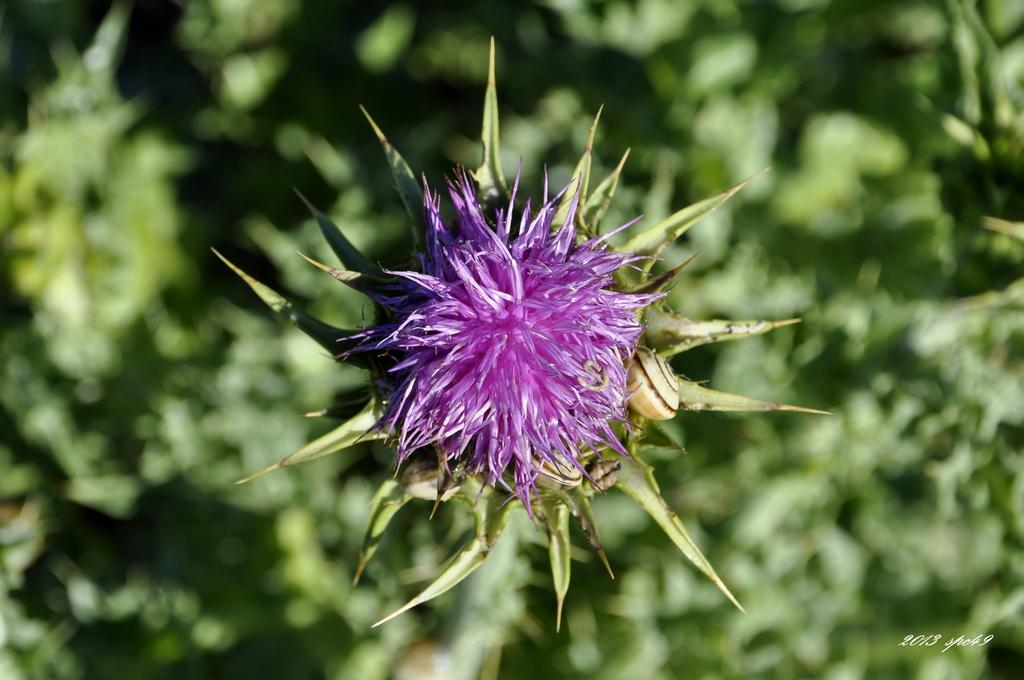What type of plant is visible in the image? There is a flower in the image. What else can be seen around the flower? There are leaves around the flower. What is written at the bottom of the image? There is some text at the bottom of the image. What else is present at the bottom of the image besides the text? There are numbers at the bottom of the image. How many pears are hanging from the flower in the image? There are no pears present in the image; it features a flower with leaves and text at the bottom. 